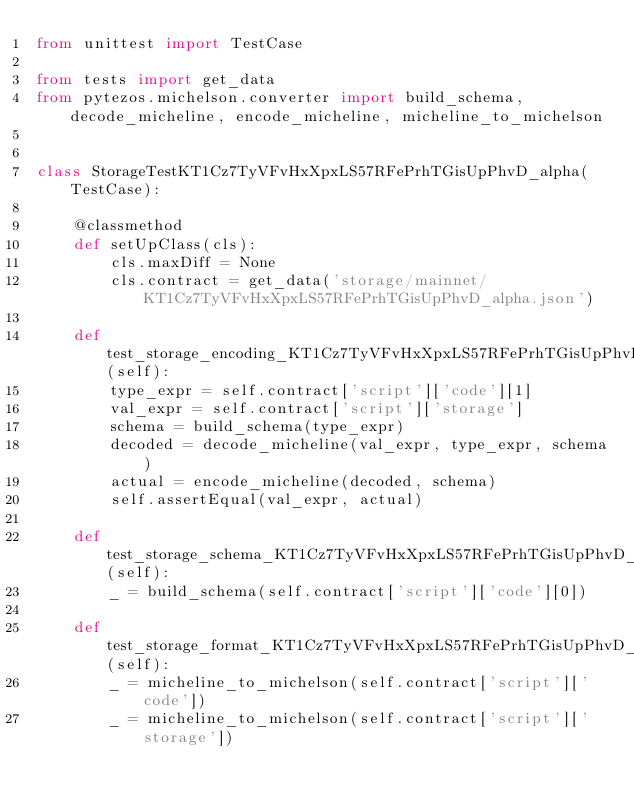<code> <loc_0><loc_0><loc_500><loc_500><_Python_>from unittest import TestCase

from tests import get_data
from pytezos.michelson.converter import build_schema, decode_micheline, encode_micheline, micheline_to_michelson


class StorageTestKT1Cz7TyVFvHxXpxLS57RFePrhTGisUpPhvD_alpha(TestCase):

    @classmethod
    def setUpClass(cls):
        cls.maxDiff = None
        cls.contract = get_data('storage/mainnet/KT1Cz7TyVFvHxXpxLS57RFePrhTGisUpPhvD_alpha.json')

    def test_storage_encoding_KT1Cz7TyVFvHxXpxLS57RFePrhTGisUpPhvD_alpha(self):
        type_expr = self.contract['script']['code'][1]
        val_expr = self.contract['script']['storage']
        schema = build_schema(type_expr)
        decoded = decode_micheline(val_expr, type_expr, schema)
        actual = encode_micheline(decoded, schema)
        self.assertEqual(val_expr, actual)

    def test_storage_schema_KT1Cz7TyVFvHxXpxLS57RFePrhTGisUpPhvD_alpha(self):
        _ = build_schema(self.contract['script']['code'][0])

    def test_storage_format_KT1Cz7TyVFvHxXpxLS57RFePrhTGisUpPhvD_alpha(self):
        _ = micheline_to_michelson(self.contract['script']['code'])
        _ = micheline_to_michelson(self.contract['script']['storage'])
</code> 